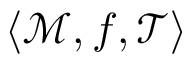Convert formula to latex. <formula><loc_0><loc_0><loc_500><loc_500>\langle { \mathcal { M } } , f , { \mathcal { T } } \rangle</formula> 